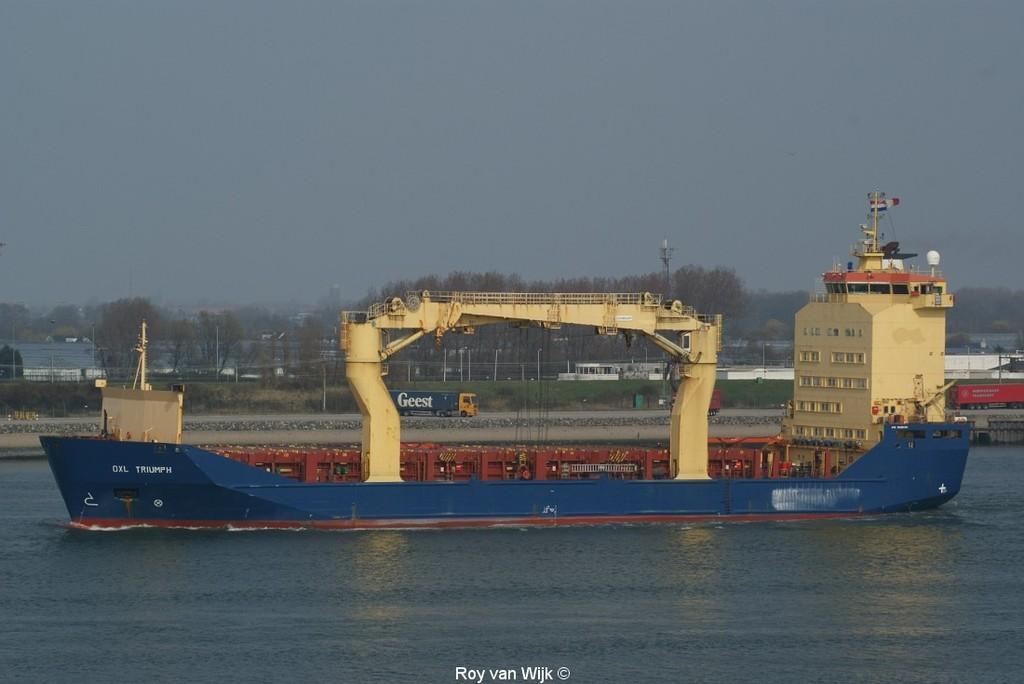In one or two sentences, can you explain what this image depicts? In this picture we can see boat, trucks, building, bridge, mesh, trees, tower are there. At the bottom of the image we can the water. At the top of the image there is a sky. 